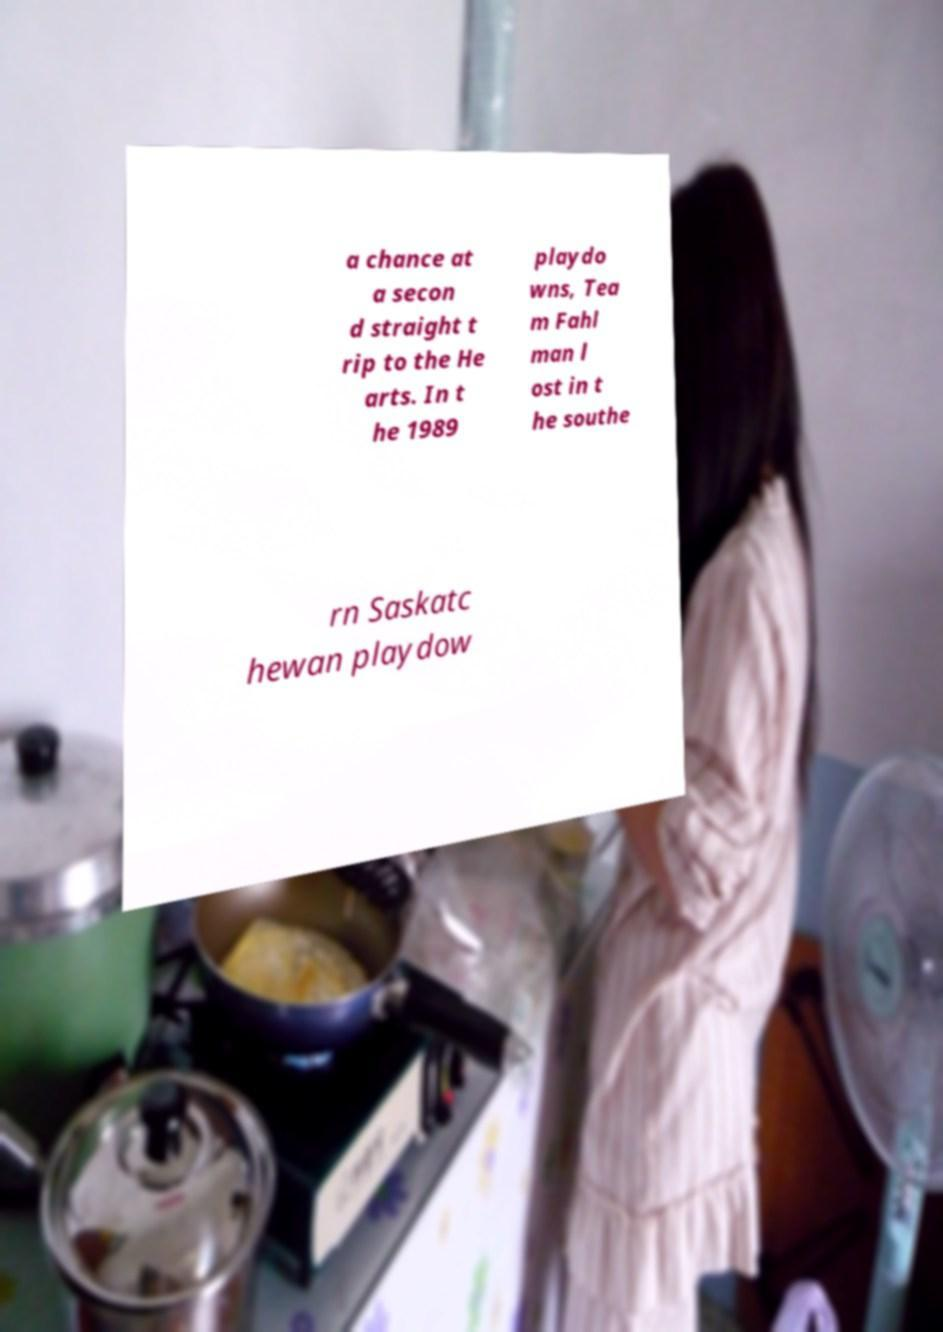Please identify and transcribe the text found in this image. a chance at a secon d straight t rip to the He arts. In t he 1989 playdo wns, Tea m Fahl man l ost in t he southe rn Saskatc hewan playdow 